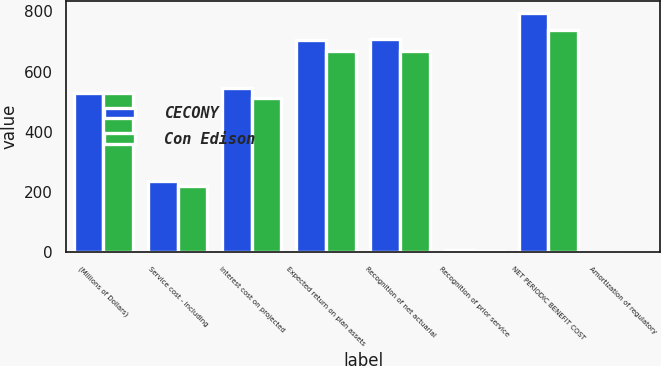<chart> <loc_0><loc_0><loc_500><loc_500><stacked_bar_chart><ecel><fcel>(Millions of Dollars)<fcel>Service cost - including<fcel>Interest cost on projected<fcel>Expected return on plan assets<fcel>Recognition of net actuarial<fcel>Recognition of prior service<fcel>NET PERIODIC BENEFIT COST<fcel>Amortization of regulatory<nl><fcel>CECONY<fcel>530<fcel>237<fcel>547<fcel>705<fcel>709<fcel>8<fcel>796<fcel>2<nl><fcel>Con Edison<fcel>530<fcel>220<fcel>513<fcel>670<fcel>670<fcel>6<fcel>739<fcel>2<nl></chart> 